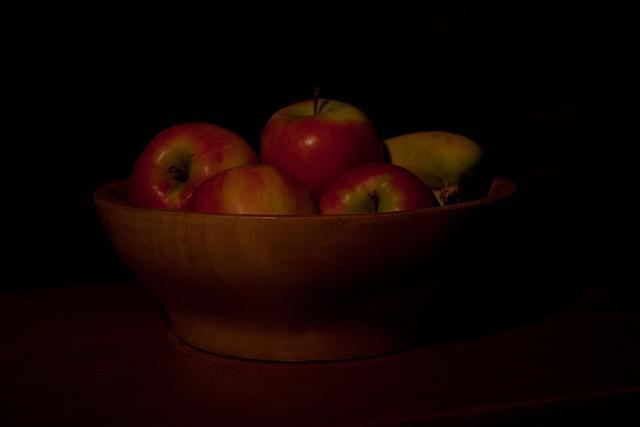How many different colors are in this picture?
Give a very brief answer. 4. How many types of fruit are in the bowl?
Give a very brief answer. 2. How many apples are in the picture?
Give a very brief answer. 5. How many different fruits are in the bowl?
Give a very brief answer. 2. How many of these do you usually peel before eating?
Give a very brief answer. 1. How many different foods are on the table?
Give a very brief answer. 2. How many types of fruit are there in the image?
Give a very brief answer. 2. How many different fruits can be seen?
Give a very brief answer. 2. How many apples can be seen?
Give a very brief answer. 3. 